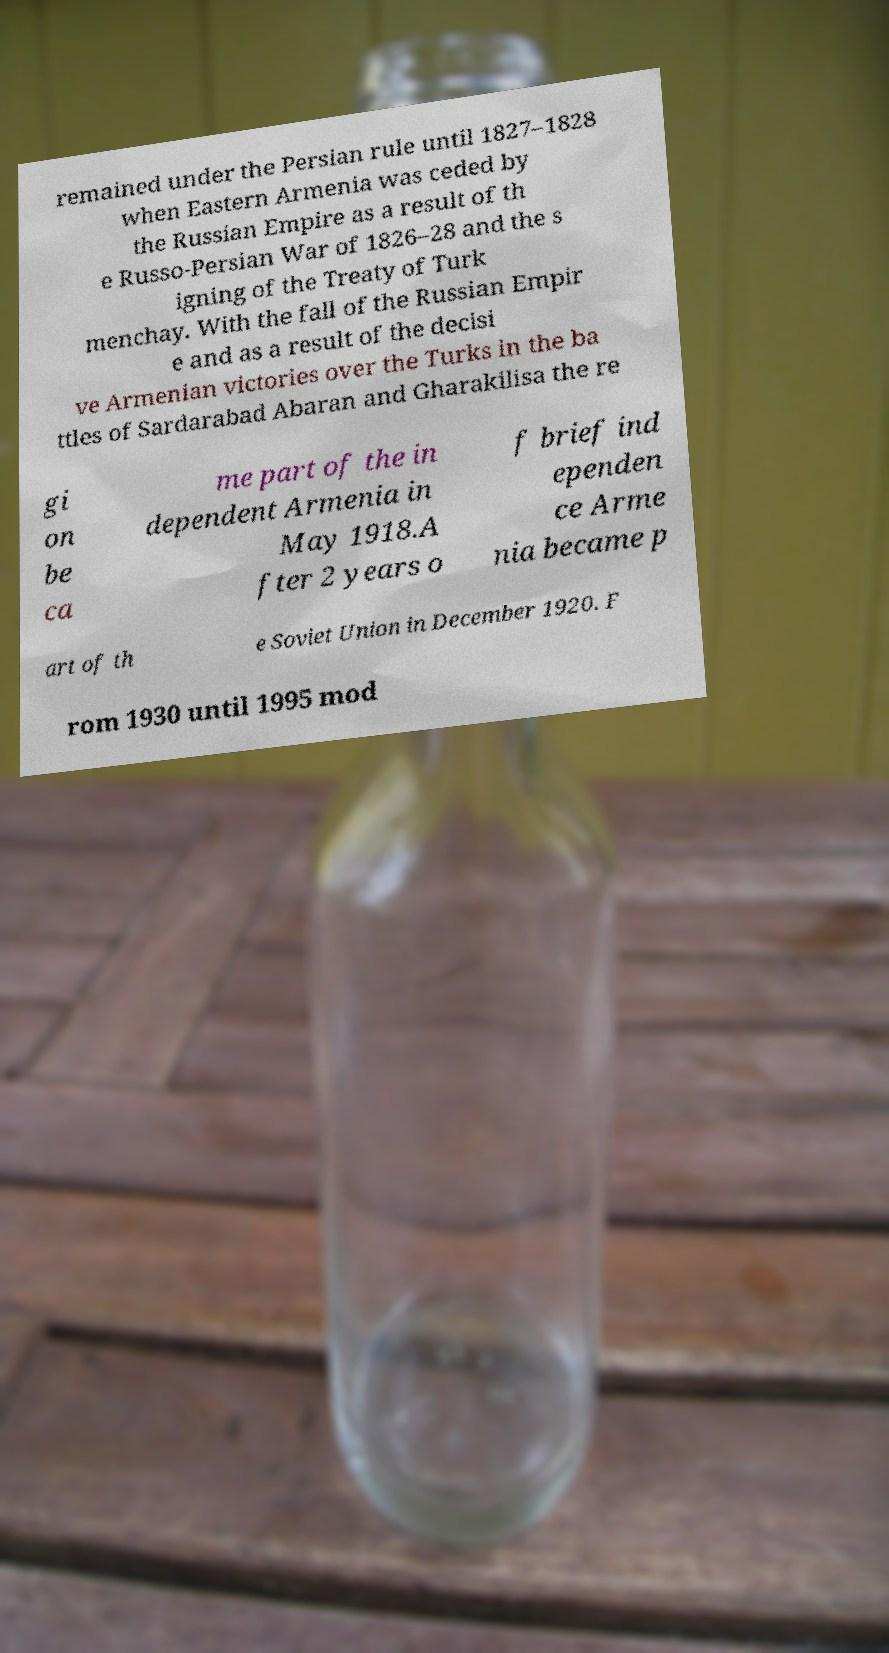Can you read and provide the text displayed in the image?This photo seems to have some interesting text. Can you extract and type it out for me? remained under the Persian rule until 1827–1828 when Eastern Armenia was ceded by the Russian Empire as a result of th e Russo-Persian War of 1826–28 and the s igning of the Treaty of Turk menchay. With the fall of the Russian Empir e and as a result of the decisi ve Armenian victories over the Turks in the ba ttles of Sardarabad Abaran and Gharakilisa the re gi on be ca me part of the in dependent Armenia in May 1918.A fter 2 years o f brief ind ependen ce Arme nia became p art of th e Soviet Union in December 1920. F rom 1930 until 1995 mod 